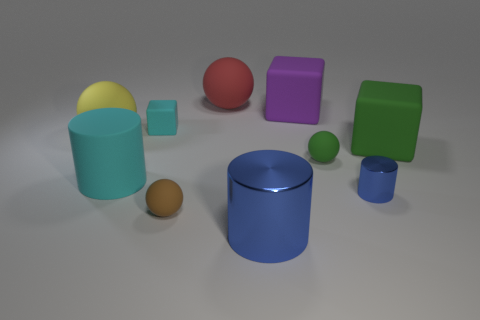Subtract all brown matte balls. How many balls are left? 3 Subtract all cyan cylinders. How many cylinders are left? 2 Subtract 3 cylinders. How many cylinders are left? 0 Subtract all purple cylinders. How many red cubes are left? 0 Subtract all balls. How many objects are left? 6 Subtract all green cubes. Subtract all red cylinders. How many cubes are left? 2 Subtract all small brown rubber cylinders. Subtract all big cyan cylinders. How many objects are left? 9 Add 3 big things. How many big things are left? 9 Add 7 brown rubber balls. How many brown rubber balls exist? 8 Subtract 1 brown spheres. How many objects are left? 9 